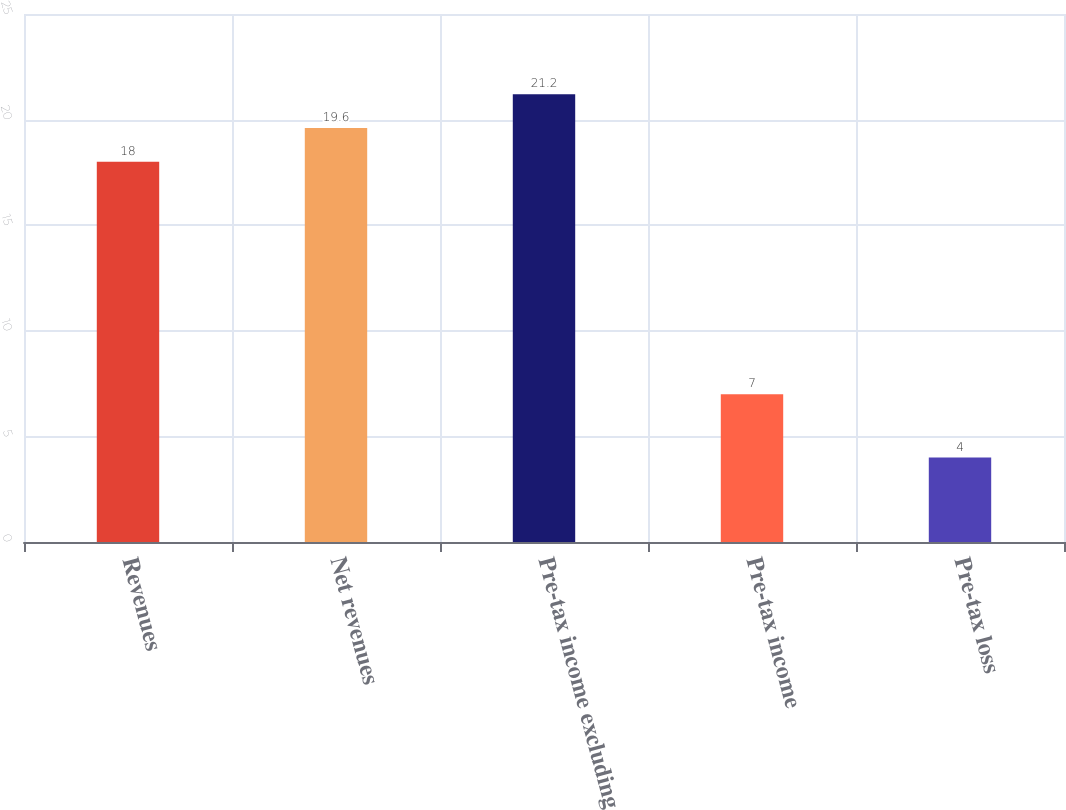<chart> <loc_0><loc_0><loc_500><loc_500><bar_chart><fcel>Revenues<fcel>Net revenues<fcel>Pre-tax income excluding<fcel>Pre-tax income<fcel>Pre-tax loss<nl><fcel>18<fcel>19.6<fcel>21.2<fcel>7<fcel>4<nl></chart> 